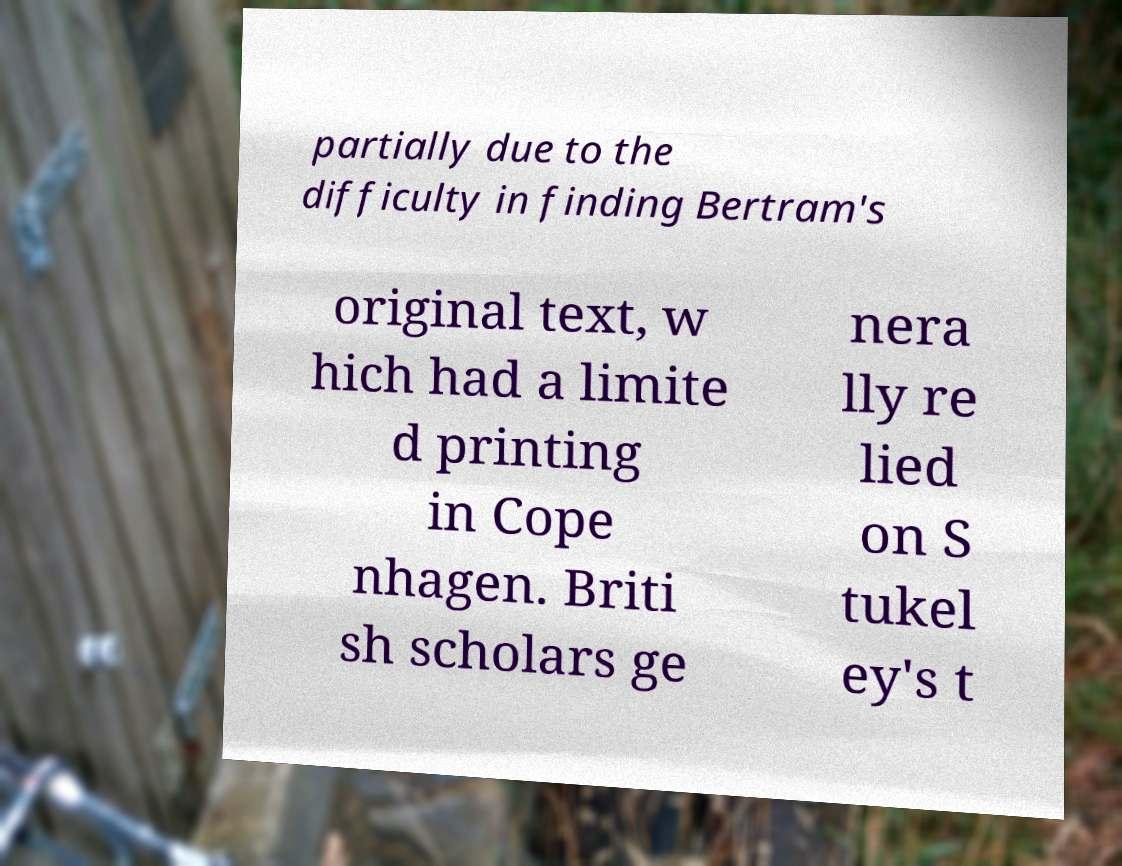Could you extract and type out the text from this image? partially due to the difficulty in finding Bertram's original text, w hich had a limite d printing in Cope nhagen. Briti sh scholars ge nera lly re lied on S tukel ey's t 